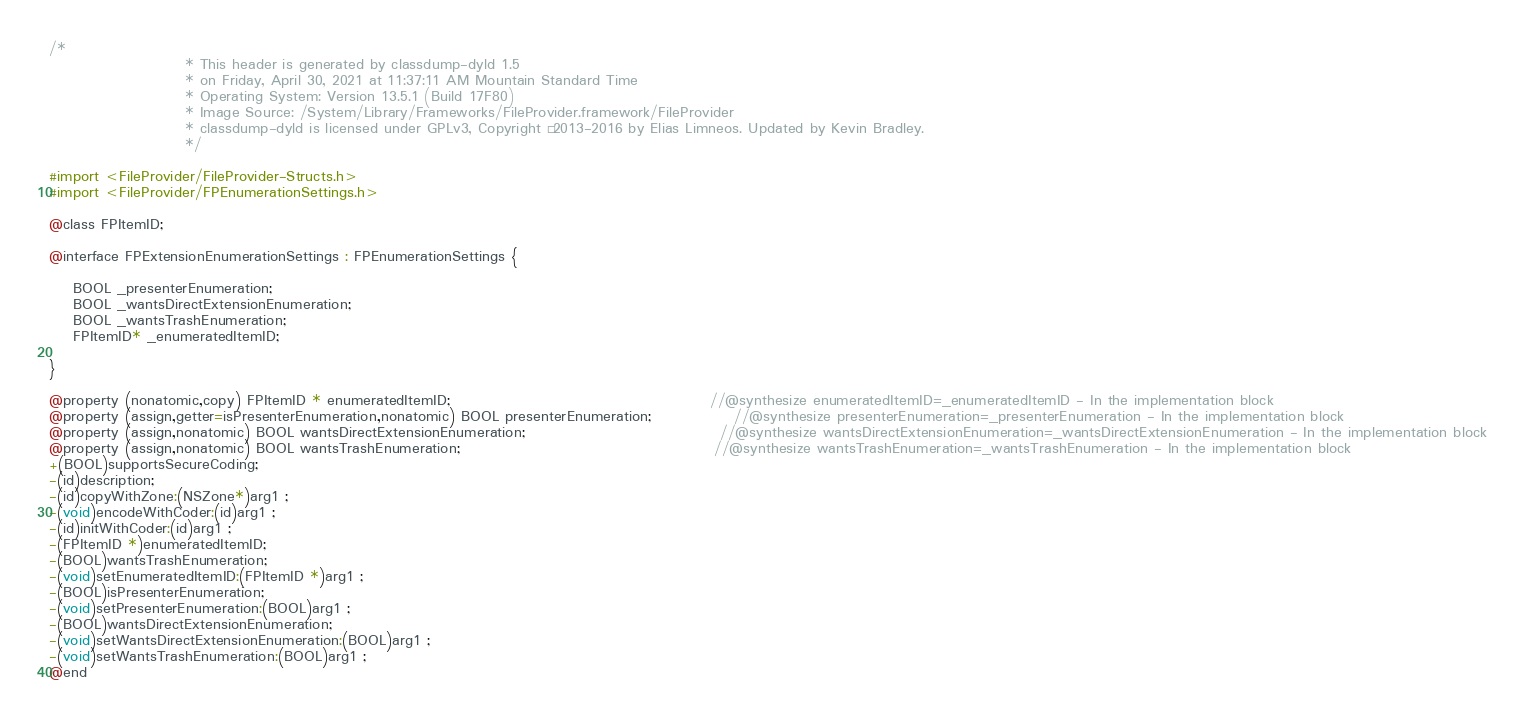Convert code to text. <code><loc_0><loc_0><loc_500><loc_500><_C_>/*
                       * This header is generated by classdump-dyld 1.5
                       * on Friday, April 30, 2021 at 11:37:11 AM Mountain Standard Time
                       * Operating System: Version 13.5.1 (Build 17F80)
                       * Image Source: /System/Library/Frameworks/FileProvider.framework/FileProvider
                       * classdump-dyld is licensed under GPLv3, Copyright © 2013-2016 by Elias Limneos. Updated by Kevin Bradley.
                       */

#import <FileProvider/FileProvider-Structs.h>
#import <FileProvider/FPEnumerationSettings.h>

@class FPItemID;

@interface FPExtensionEnumerationSettings : FPEnumerationSettings {

	BOOL _presenterEnumeration;
	BOOL _wantsDirectExtensionEnumeration;
	BOOL _wantsTrashEnumeration;
	FPItemID* _enumeratedItemID;

}

@property (nonatomic,copy) FPItemID * enumeratedItemID;                                            //@synthesize enumeratedItemID=_enumeratedItemID - In the implementation block
@property (assign,getter=isPresenterEnumeration,nonatomic) BOOL presenterEnumeration;              //@synthesize presenterEnumeration=_presenterEnumeration - In the implementation block
@property (assign,nonatomic) BOOL wantsDirectExtensionEnumeration;                                 //@synthesize wantsDirectExtensionEnumeration=_wantsDirectExtensionEnumeration - In the implementation block
@property (assign,nonatomic) BOOL wantsTrashEnumeration;                                           //@synthesize wantsTrashEnumeration=_wantsTrashEnumeration - In the implementation block
+(BOOL)supportsSecureCoding;
-(id)description;
-(id)copyWithZone:(NSZone*)arg1 ;
-(void)encodeWithCoder:(id)arg1 ;
-(id)initWithCoder:(id)arg1 ;
-(FPItemID *)enumeratedItemID;
-(BOOL)wantsTrashEnumeration;
-(void)setEnumeratedItemID:(FPItemID *)arg1 ;
-(BOOL)isPresenterEnumeration;
-(void)setPresenterEnumeration:(BOOL)arg1 ;
-(BOOL)wantsDirectExtensionEnumeration;
-(void)setWantsDirectExtensionEnumeration:(BOOL)arg1 ;
-(void)setWantsTrashEnumeration:(BOOL)arg1 ;
@end

</code> 